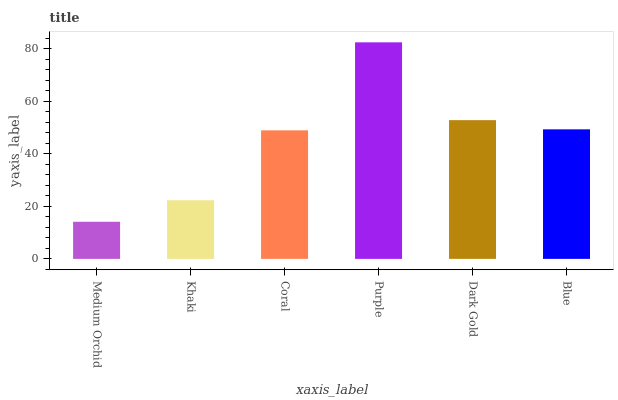Is Medium Orchid the minimum?
Answer yes or no. Yes. Is Purple the maximum?
Answer yes or no. Yes. Is Khaki the minimum?
Answer yes or no. No. Is Khaki the maximum?
Answer yes or no. No. Is Khaki greater than Medium Orchid?
Answer yes or no. Yes. Is Medium Orchid less than Khaki?
Answer yes or no. Yes. Is Medium Orchid greater than Khaki?
Answer yes or no. No. Is Khaki less than Medium Orchid?
Answer yes or no. No. Is Blue the high median?
Answer yes or no. Yes. Is Coral the low median?
Answer yes or no. Yes. Is Khaki the high median?
Answer yes or no. No. Is Dark Gold the low median?
Answer yes or no. No. 